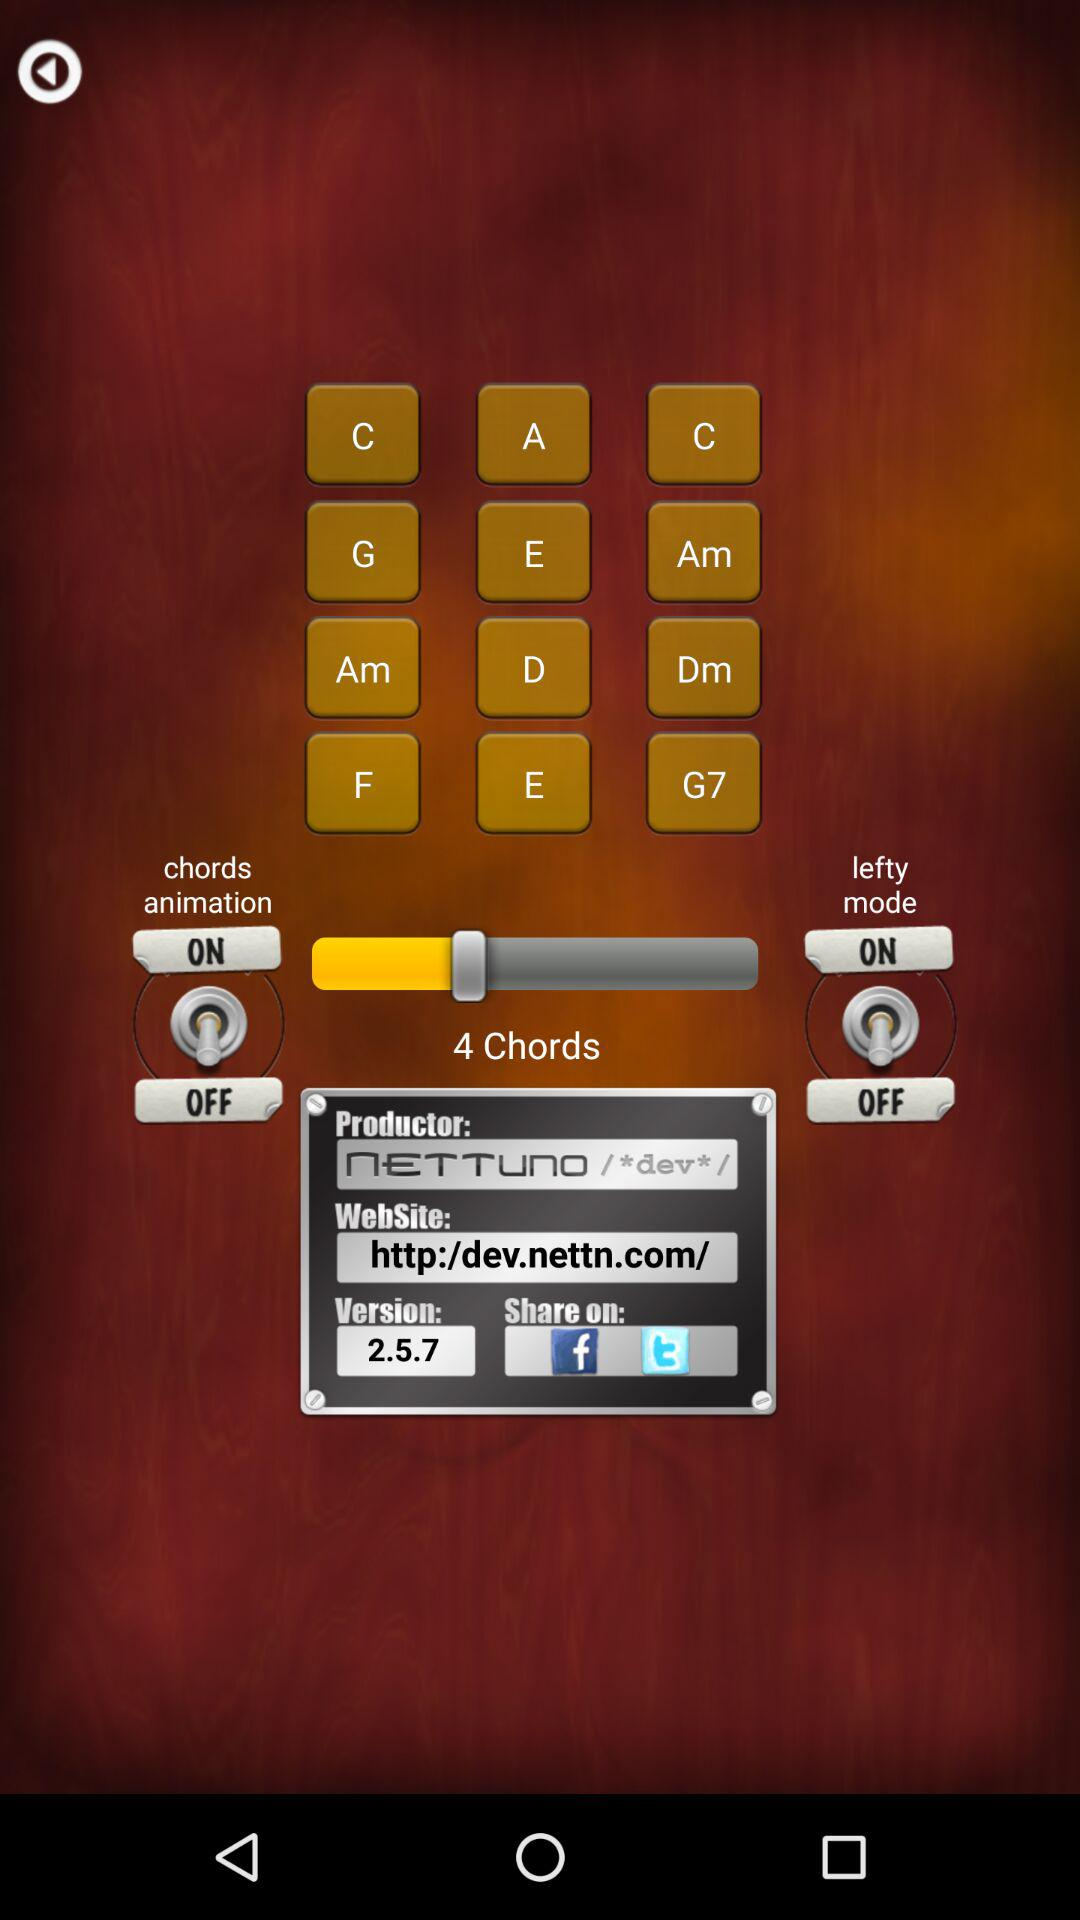What is the name of the application?
When the provided information is insufficient, respond with <no answer>. <no answer> 